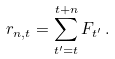<formula> <loc_0><loc_0><loc_500><loc_500>r _ { n , t } = \sum _ { t ^ { \prime } = t } ^ { t + n } F _ { t ^ { \prime } } \, .</formula> 